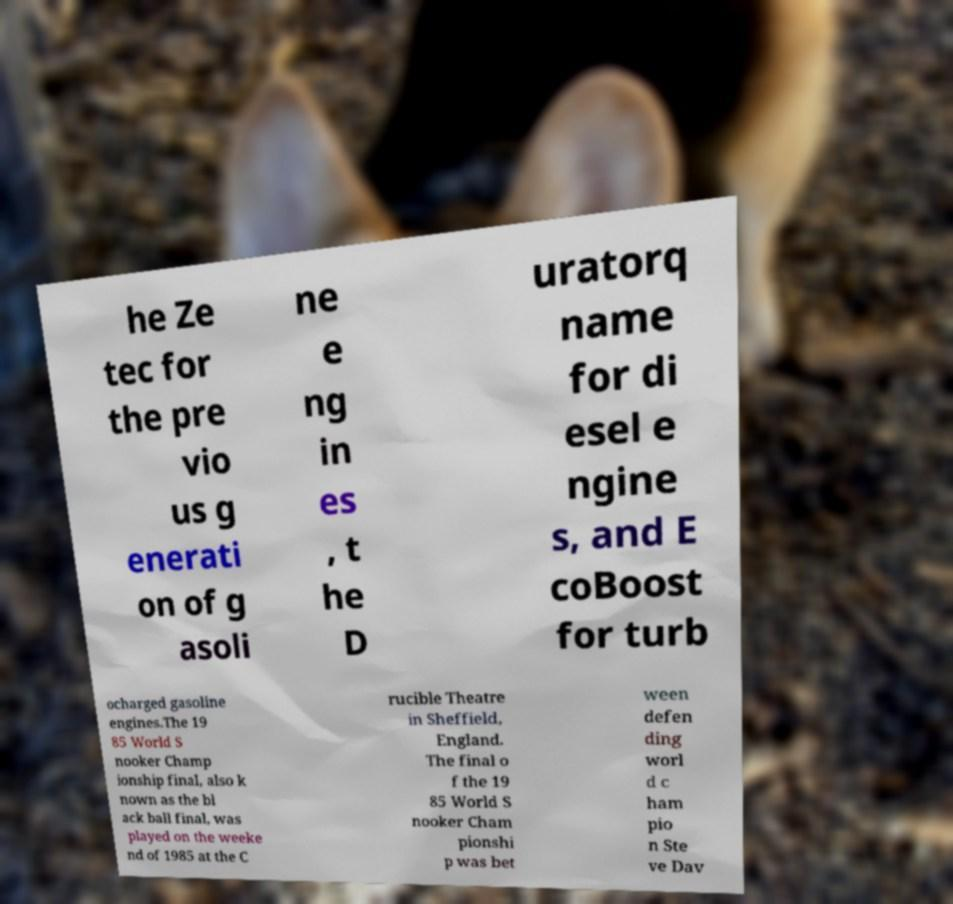Could you assist in decoding the text presented in this image and type it out clearly? he Ze tec for the pre vio us g enerati on of g asoli ne e ng in es , t he D uratorq name for di esel e ngine s, and E coBoost for turb ocharged gasoline engines.The 19 85 World S nooker Champ ionship final, also k nown as the bl ack ball final, was played on the weeke nd of 1985 at the C rucible Theatre in Sheffield, England. The final o f the 19 85 World S nooker Cham pionshi p was bet ween defen ding worl d c ham pio n Ste ve Dav 